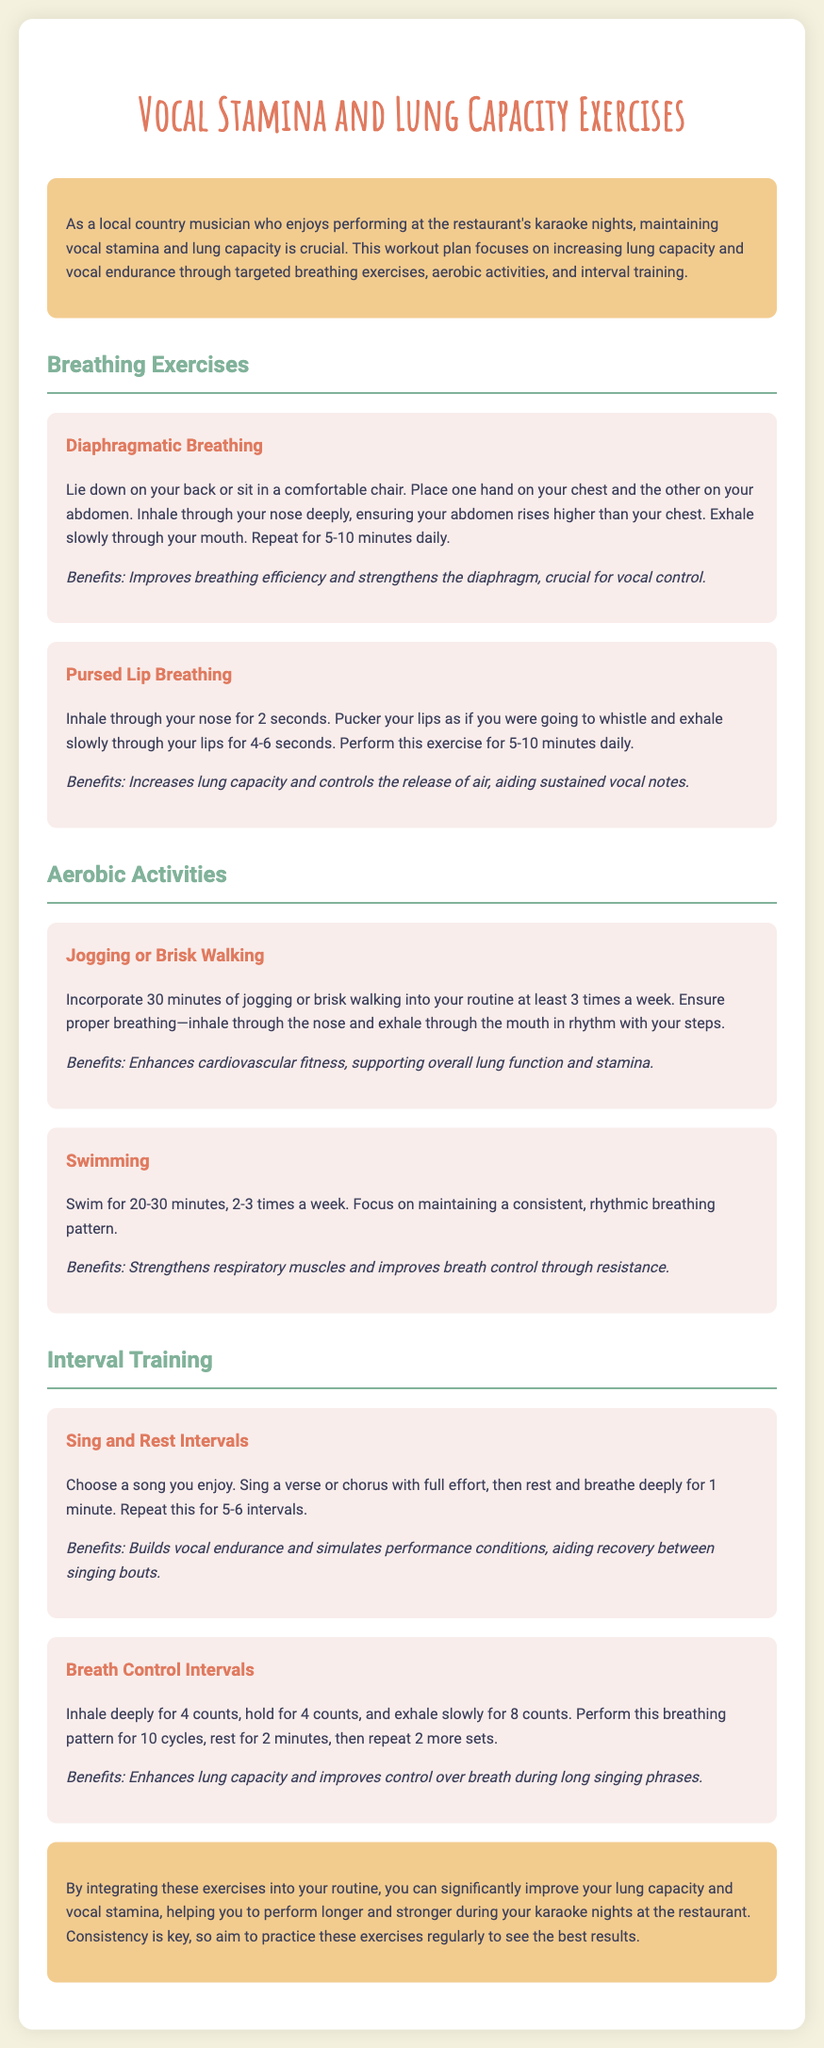what is the title of the workout plan? The title of the workout plan is stated prominently at the top of the document.
Answer: Vocal Stamina and Lung Capacity Exercises how long should you practice diaphragmatic breathing daily? The document specifies a recommended duration for this exercise.
Answer: 5-10 minutes how many times a week should you incorporate jogging or brisk walking? The frequency of this activity is outlined in the aerobic activities section.
Answer: At least 3 times a week what are the benefits of pursed lip breathing? The document lists the benefits directly following the description of the exercise.
Answer: Increases lung capacity and controls the release of air what exercise simulates performance conditions? The document describes an interval training exercise that helps with this aspect.
Answer: Sing and Rest Intervals how many cycles should you perform for breath control intervals? The number of cycles is mentioned in the description of the exercise.
Answer: 10 cycles what is important for swimming according to the document? The document emphasizes a specific aspect of breathing during this aerobic activity.
Answer: Consistent, rhythmic breathing pattern what is the key to see the best results from the workout plan? The conclusion provides advice on achieving optimal outcomes from the exercises.
Answer: Consistency 